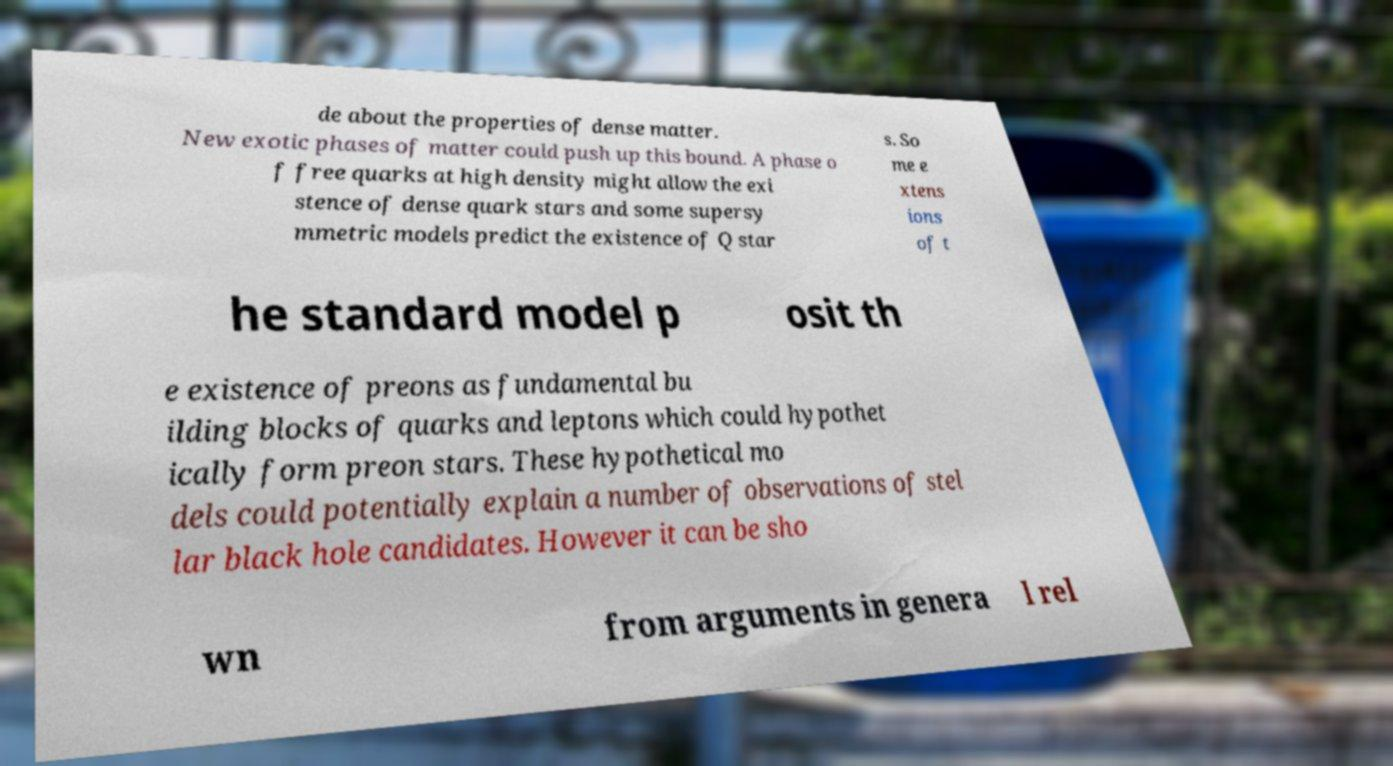Can you accurately transcribe the text from the provided image for me? de about the properties of dense matter. New exotic phases of matter could push up this bound. A phase o f free quarks at high density might allow the exi stence of dense quark stars and some supersy mmetric models predict the existence of Q star s. So me e xtens ions of t he standard model p osit th e existence of preons as fundamental bu ilding blocks of quarks and leptons which could hypothet ically form preon stars. These hypothetical mo dels could potentially explain a number of observations of stel lar black hole candidates. However it can be sho wn from arguments in genera l rel 